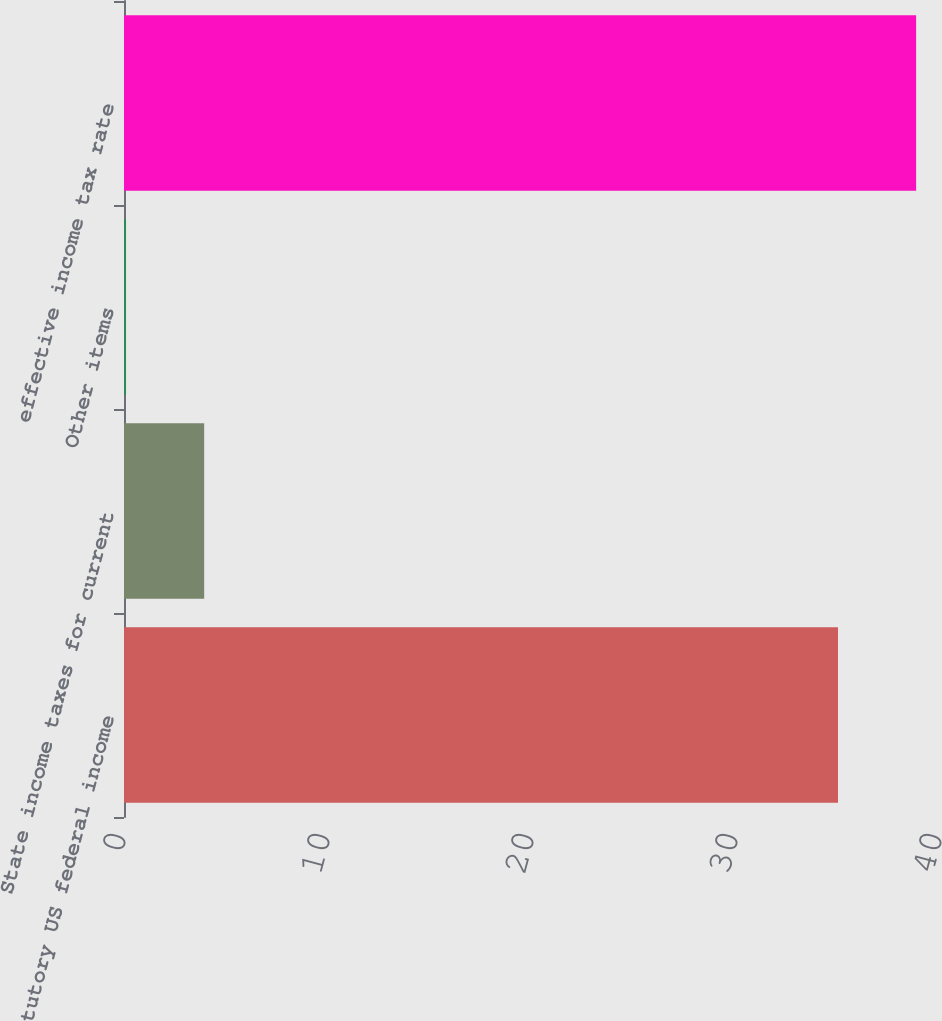<chart> <loc_0><loc_0><loc_500><loc_500><bar_chart><fcel>Statutory US federal income<fcel>State income taxes for current<fcel>Other items<fcel>effective income tax rate<nl><fcel>35<fcel>3.93<fcel>0.1<fcel>38.83<nl></chart> 